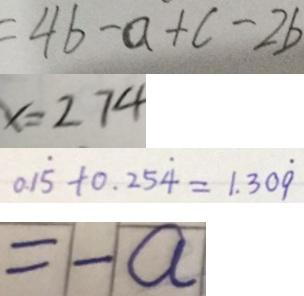<formula> <loc_0><loc_0><loc_500><loc_500>= 4 b - a + c - 2 b 
 x = 2 7 4 
 0 1 \dot { 5 } + 0 . 2 5 \dot { 4 } = 1 . 3 0 \dot { 9 } 
 = - a</formula> 